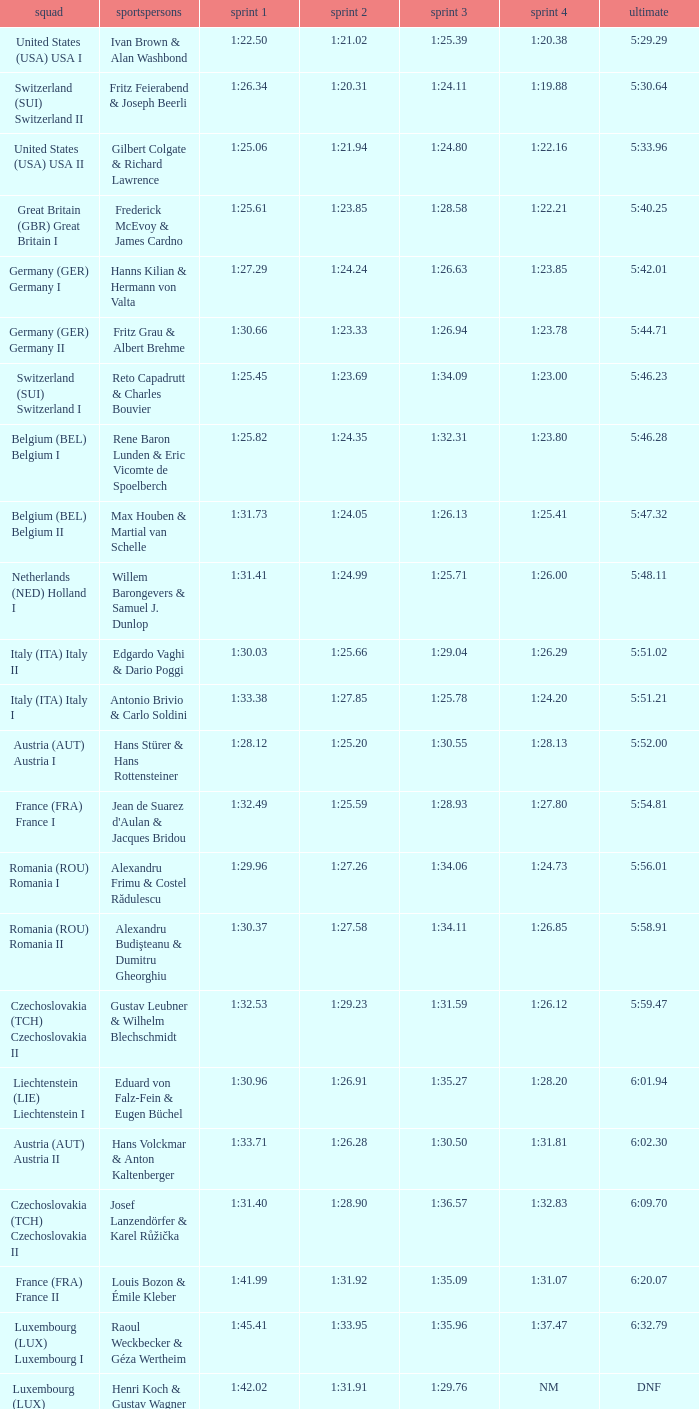Which Run 4 has Athletes of alexandru frimu & costel rădulescu? 1:24.73. 